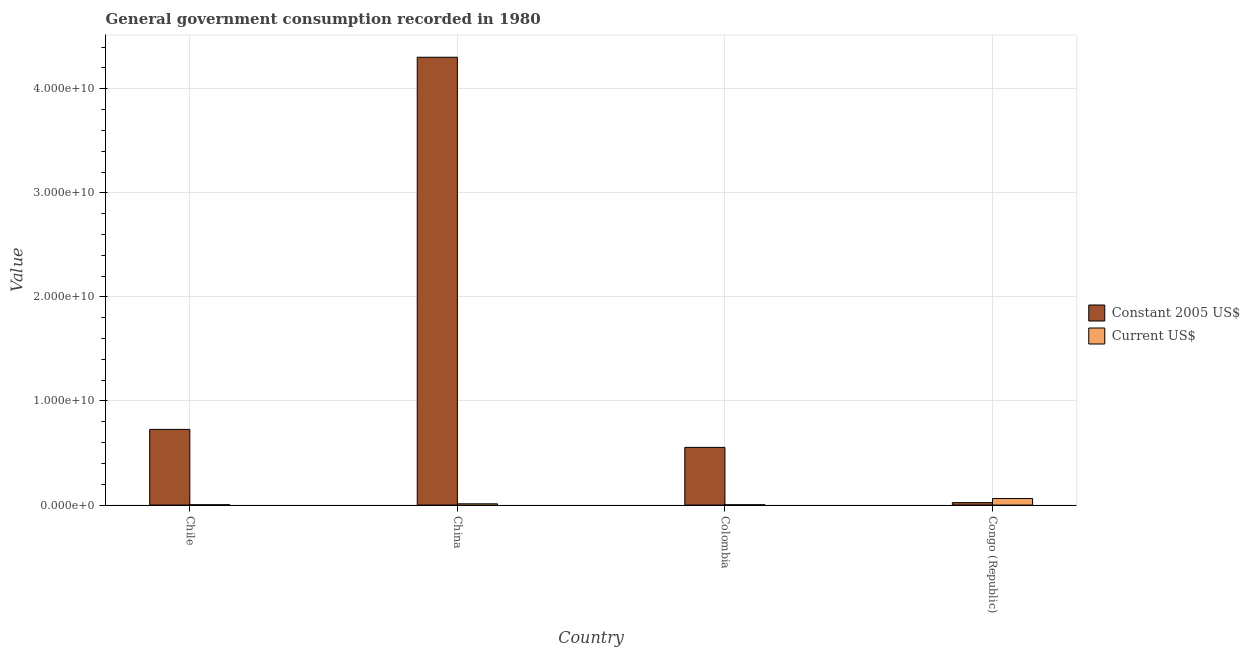How many groups of bars are there?
Offer a very short reply. 4. Are the number of bars per tick equal to the number of legend labels?
Your answer should be very brief. Yes. How many bars are there on the 2nd tick from the left?
Offer a terse response. 2. In how many cases, is the number of bars for a given country not equal to the number of legend labels?
Your response must be concise. 0. What is the value consumed in current us$ in Chile?
Ensure brevity in your answer.  3.34e+07. Across all countries, what is the maximum value consumed in current us$?
Make the answer very short. 6.28e+08. Across all countries, what is the minimum value consumed in current us$?
Offer a very short reply. 3.11e+07. In which country was the value consumed in constant 2005 us$ minimum?
Ensure brevity in your answer.  Congo (Republic). What is the total value consumed in constant 2005 us$ in the graph?
Your response must be concise. 5.61e+1. What is the difference between the value consumed in constant 2005 us$ in Chile and that in Congo (Republic)?
Your answer should be very brief. 7.04e+09. What is the difference between the value consumed in current us$ in Chile and the value consumed in constant 2005 us$ in Colombia?
Provide a succinct answer. -5.51e+09. What is the average value consumed in current us$ per country?
Give a very brief answer. 2.03e+08. What is the difference between the value consumed in constant 2005 us$ and value consumed in current us$ in China?
Offer a very short reply. 4.29e+1. In how many countries, is the value consumed in current us$ greater than 42000000000 ?
Make the answer very short. 0. What is the ratio of the value consumed in current us$ in Chile to that in Colombia?
Give a very brief answer. 1.08. Is the difference between the value consumed in constant 2005 us$ in China and Colombia greater than the difference between the value consumed in current us$ in China and Colombia?
Offer a very short reply. Yes. What is the difference between the highest and the second highest value consumed in constant 2005 us$?
Provide a short and direct response. 3.58e+1. What is the difference between the highest and the lowest value consumed in constant 2005 us$?
Your response must be concise. 4.28e+1. What does the 1st bar from the left in Chile represents?
Offer a very short reply. Constant 2005 US$. What does the 2nd bar from the right in Congo (Republic) represents?
Your answer should be very brief. Constant 2005 US$. How many bars are there?
Offer a terse response. 8. Are the values on the major ticks of Y-axis written in scientific E-notation?
Your answer should be compact. Yes. Does the graph contain grids?
Offer a very short reply. Yes. Where does the legend appear in the graph?
Provide a succinct answer. Center right. How many legend labels are there?
Provide a succinct answer. 2. What is the title of the graph?
Give a very brief answer. General government consumption recorded in 1980. Does "Boys" appear as one of the legend labels in the graph?
Your answer should be very brief. No. What is the label or title of the Y-axis?
Ensure brevity in your answer.  Value. What is the Value in Constant 2005 US$ in Chile?
Provide a short and direct response. 7.27e+09. What is the Value of Current US$ in Chile?
Provide a short and direct response. 3.34e+07. What is the Value in Constant 2005 US$ in China?
Offer a terse response. 4.30e+1. What is the Value in Current US$ in China?
Offer a terse response. 1.21e+08. What is the Value of Constant 2005 US$ in Colombia?
Give a very brief answer. 5.54e+09. What is the Value in Current US$ in Colombia?
Offer a very short reply. 3.11e+07. What is the Value of Constant 2005 US$ in Congo (Republic)?
Ensure brevity in your answer.  2.36e+08. What is the Value of Current US$ in Congo (Republic)?
Give a very brief answer. 6.28e+08. Across all countries, what is the maximum Value of Constant 2005 US$?
Provide a succinct answer. 4.30e+1. Across all countries, what is the maximum Value in Current US$?
Your response must be concise. 6.28e+08. Across all countries, what is the minimum Value of Constant 2005 US$?
Ensure brevity in your answer.  2.36e+08. Across all countries, what is the minimum Value of Current US$?
Your answer should be very brief. 3.11e+07. What is the total Value in Constant 2005 US$ in the graph?
Keep it short and to the point. 5.61e+1. What is the total Value of Current US$ in the graph?
Make the answer very short. 8.14e+08. What is the difference between the Value of Constant 2005 US$ in Chile and that in China?
Keep it short and to the point. -3.58e+1. What is the difference between the Value of Current US$ in Chile and that in China?
Ensure brevity in your answer.  -8.81e+07. What is the difference between the Value in Constant 2005 US$ in Chile and that in Colombia?
Your answer should be compact. 1.73e+09. What is the difference between the Value in Current US$ in Chile and that in Colombia?
Your answer should be compact. 2.35e+06. What is the difference between the Value of Constant 2005 US$ in Chile and that in Congo (Republic)?
Offer a very short reply. 7.04e+09. What is the difference between the Value in Current US$ in Chile and that in Congo (Republic)?
Provide a succinct answer. -5.95e+08. What is the difference between the Value in Constant 2005 US$ in China and that in Colombia?
Make the answer very short. 3.75e+1. What is the difference between the Value of Current US$ in China and that in Colombia?
Ensure brevity in your answer.  9.04e+07. What is the difference between the Value in Constant 2005 US$ in China and that in Congo (Republic)?
Your answer should be compact. 4.28e+1. What is the difference between the Value of Current US$ in China and that in Congo (Republic)?
Your answer should be compact. -5.07e+08. What is the difference between the Value of Constant 2005 US$ in Colombia and that in Congo (Republic)?
Make the answer very short. 5.31e+09. What is the difference between the Value of Current US$ in Colombia and that in Congo (Republic)?
Offer a terse response. -5.97e+08. What is the difference between the Value in Constant 2005 US$ in Chile and the Value in Current US$ in China?
Make the answer very short. 7.15e+09. What is the difference between the Value of Constant 2005 US$ in Chile and the Value of Current US$ in Colombia?
Your answer should be compact. 7.24e+09. What is the difference between the Value in Constant 2005 US$ in Chile and the Value in Current US$ in Congo (Republic)?
Offer a terse response. 6.64e+09. What is the difference between the Value of Constant 2005 US$ in China and the Value of Current US$ in Colombia?
Offer a very short reply. 4.30e+1. What is the difference between the Value in Constant 2005 US$ in China and the Value in Current US$ in Congo (Republic)?
Provide a succinct answer. 4.24e+1. What is the difference between the Value in Constant 2005 US$ in Colombia and the Value in Current US$ in Congo (Republic)?
Ensure brevity in your answer.  4.92e+09. What is the average Value in Constant 2005 US$ per country?
Provide a succinct answer. 1.40e+1. What is the average Value in Current US$ per country?
Offer a terse response. 2.03e+08. What is the difference between the Value of Constant 2005 US$ and Value of Current US$ in Chile?
Your answer should be compact. 7.24e+09. What is the difference between the Value in Constant 2005 US$ and Value in Current US$ in China?
Provide a short and direct response. 4.29e+1. What is the difference between the Value in Constant 2005 US$ and Value in Current US$ in Colombia?
Give a very brief answer. 5.51e+09. What is the difference between the Value in Constant 2005 US$ and Value in Current US$ in Congo (Republic)?
Give a very brief answer. -3.92e+08. What is the ratio of the Value of Constant 2005 US$ in Chile to that in China?
Provide a short and direct response. 0.17. What is the ratio of the Value of Current US$ in Chile to that in China?
Your response must be concise. 0.28. What is the ratio of the Value of Constant 2005 US$ in Chile to that in Colombia?
Make the answer very short. 1.31. What is the ratio of the Value of Current US$ in Chile to that in Colombia?
Ensure brevity in your answer.  1.08. What is the ratio of the Value of Constant 2005 US$ in Chile to that in Congo (Republic)?
Offer a terse response. 30.84. What is the ratio of the Value of Current US$ in Chile to that in Congo (Republic)?
Your answer should be compact. 0.05. What is the ratio of the Value in Constant 2005 US$ in China to that in Colombia?
Keep it short and to the point. 7.76. What is the ratio of the Value of Current US$ in China to that in Colombia?
Ensure brevity in your answer.  3.91. What is the ratio of the Value of Constant 2005 US$ in China to that in Congo (Republic)?
Make the answer very short. 182.45. What is the ratio of the Value of Current US$ in China to that in Congo (Republic)?
Provide a succinct answer. 0.19. What is the ratio of the Value of Constant 2005 US$ in Colombia to that in Congo (Republic)?
Ensure brevity in your answer.  23.51. What is the ratio of the Value of Current US$ in Colombia to that in Congo (Republic)?
Make the answer very short. 0.05. What is the difference between the highest and the second highest Value in Constant 2005 US$?
Offer a terse response. 3.58e+1. What is the difference between the highest and the second highest Value of Current US$?
Keep it short and to the point. 5.07e+08. What is the difference between the highest and the lowest Value in Constant 2005 US$?
Your response must be concise. 4.28e+1. What is the difference between the highest and the lowest Value in Current US$?
Make the answer very short. 5.97e+08. 